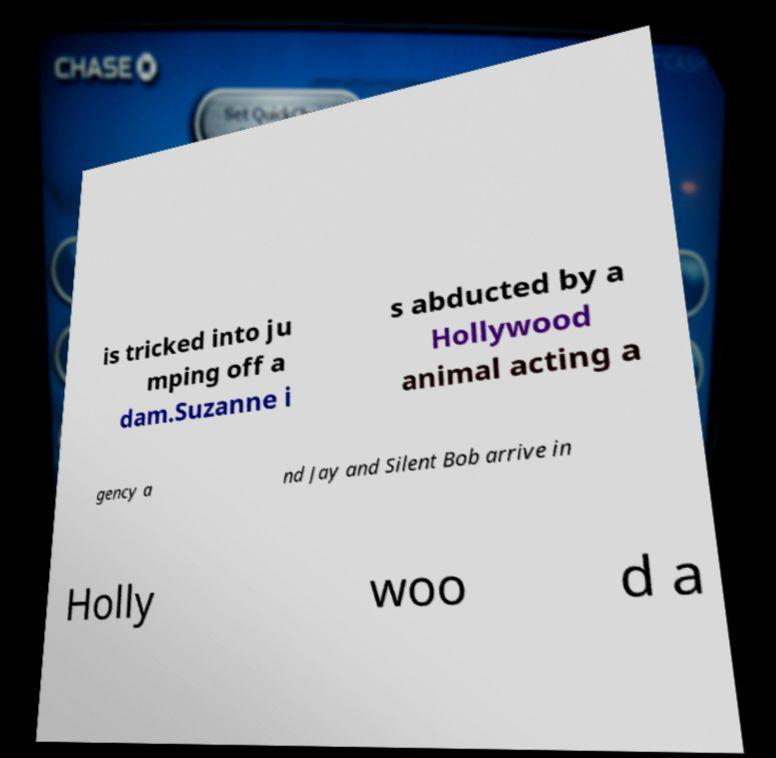Can you accurately transcribe the text from the provided image for me? is tricked into ju mping off a dam.Suzanne i s abducted by a Hollywood animal acting a gency a nd Jay and Silent Bob arrive in Holly woo d a 